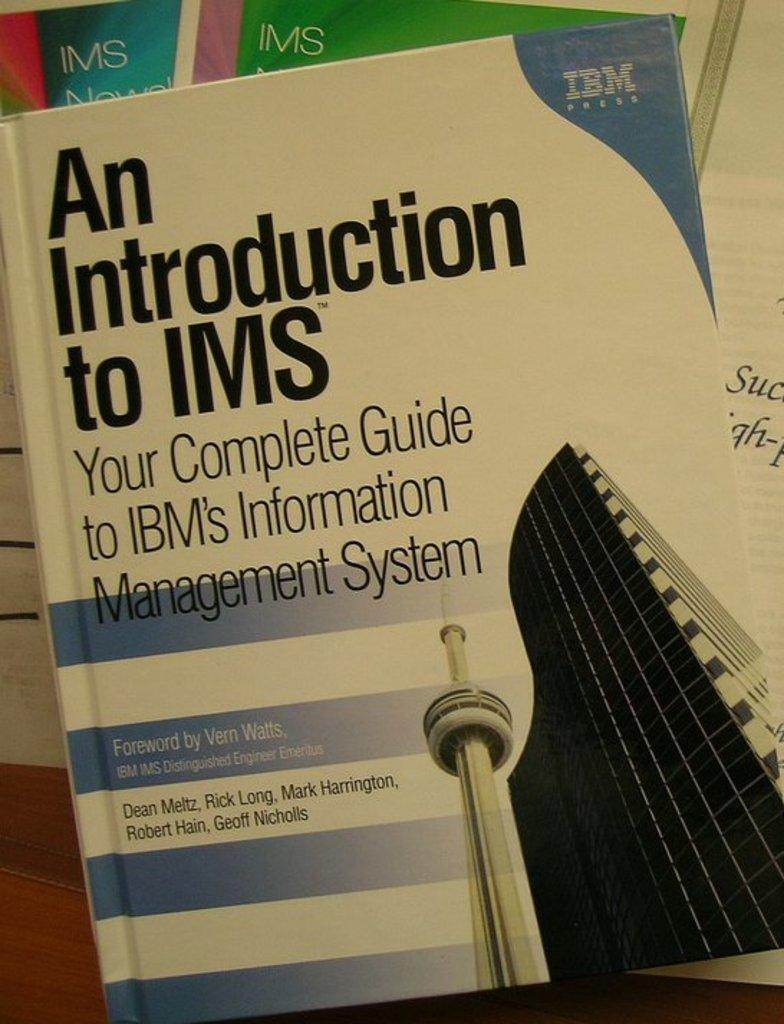<image>
Present a compact description of the photo's key features. A book from IBM titled An Introduction to IMS. 